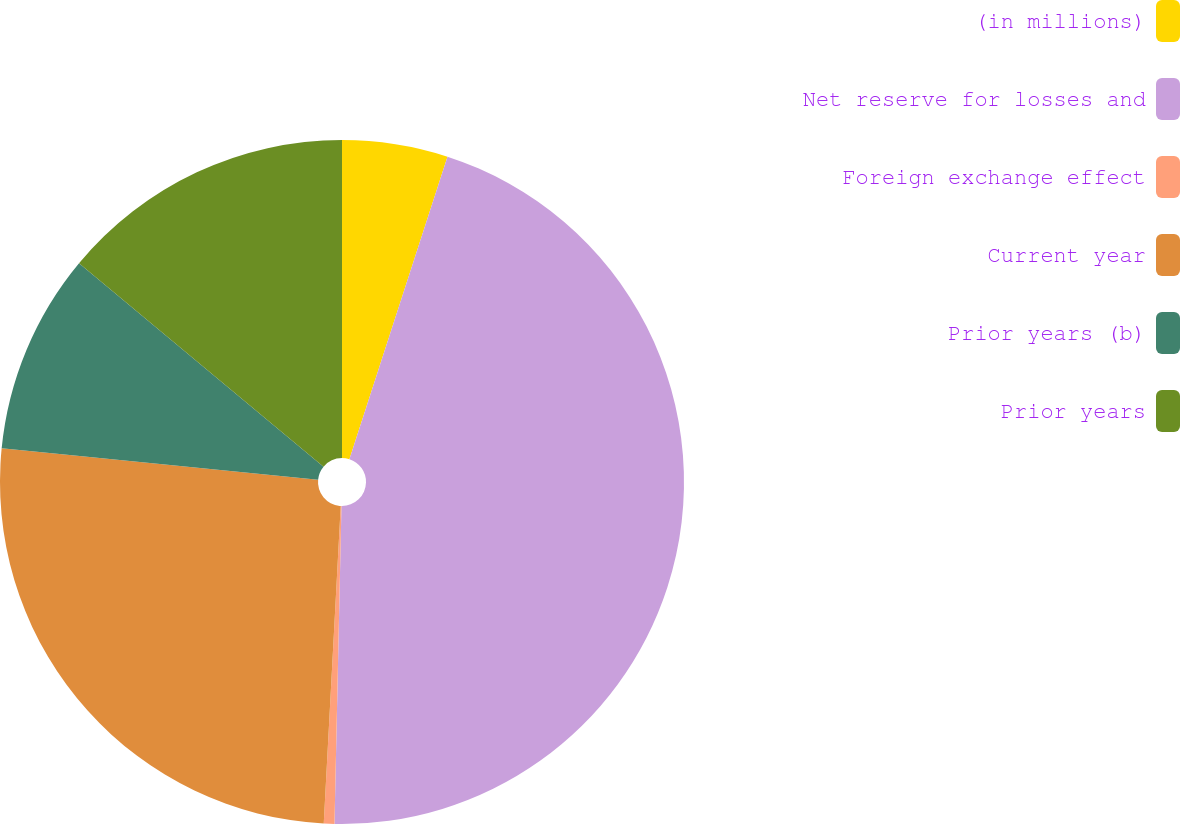Convert chart to OTSL. <chart><loc_0><loc_0><loc_500><loc_500><pie_chart><fcel>(in millions)<fcel>Net reserve for losses and<fcel>Foreign exchange effect<fcel>Current year<fcel>Prior years (b)<fcel>Prior years<nl><fcel>4.99%<fcel>45.36%<fcel>0.5%<fcel>25.72%<fcel>9.47%<fcel>13.96%<nl></chart> 